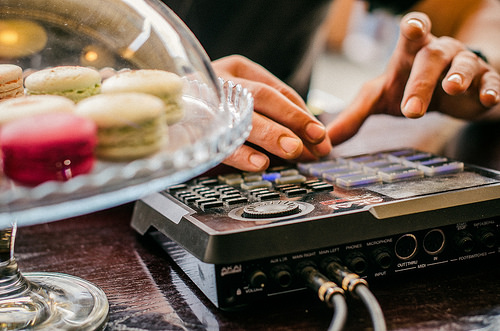<image>
Is there a man on the keyboard? No. The man is not positioned on the keyboard. They may be near each other, but the man is not supported by or resting on top of the keyboard. Is there a cookie plate next to the desk? No. The cookie plate is not positioned next to the desk. They are located in different areas of the scene. 